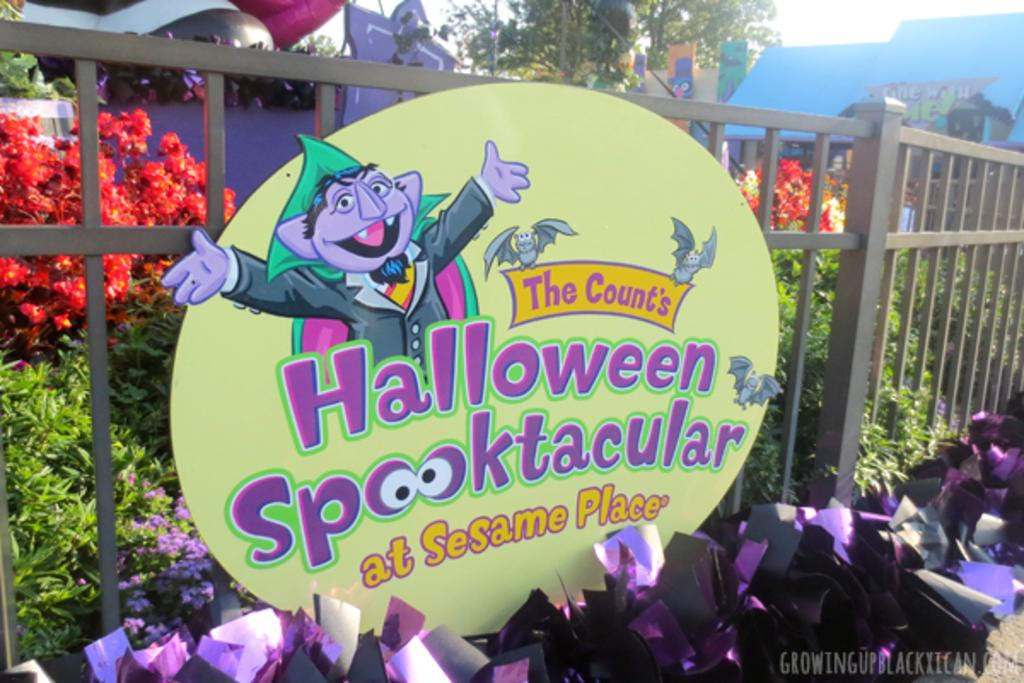What type of living organisms can be seen in the image? Plants and a tree are visible in the image. What type of barrier is present in the image? There is a metal fence in the image. What is attached to the fence in the image? There is a board with text attached to the fence. What text can be seen at the bottom right corner of the image? There is text visible at the bottom right corner of the image. What type of meat is being used to measure the distance between the plants in the image? There is no meat present in the image, and the plants are not being measured. 